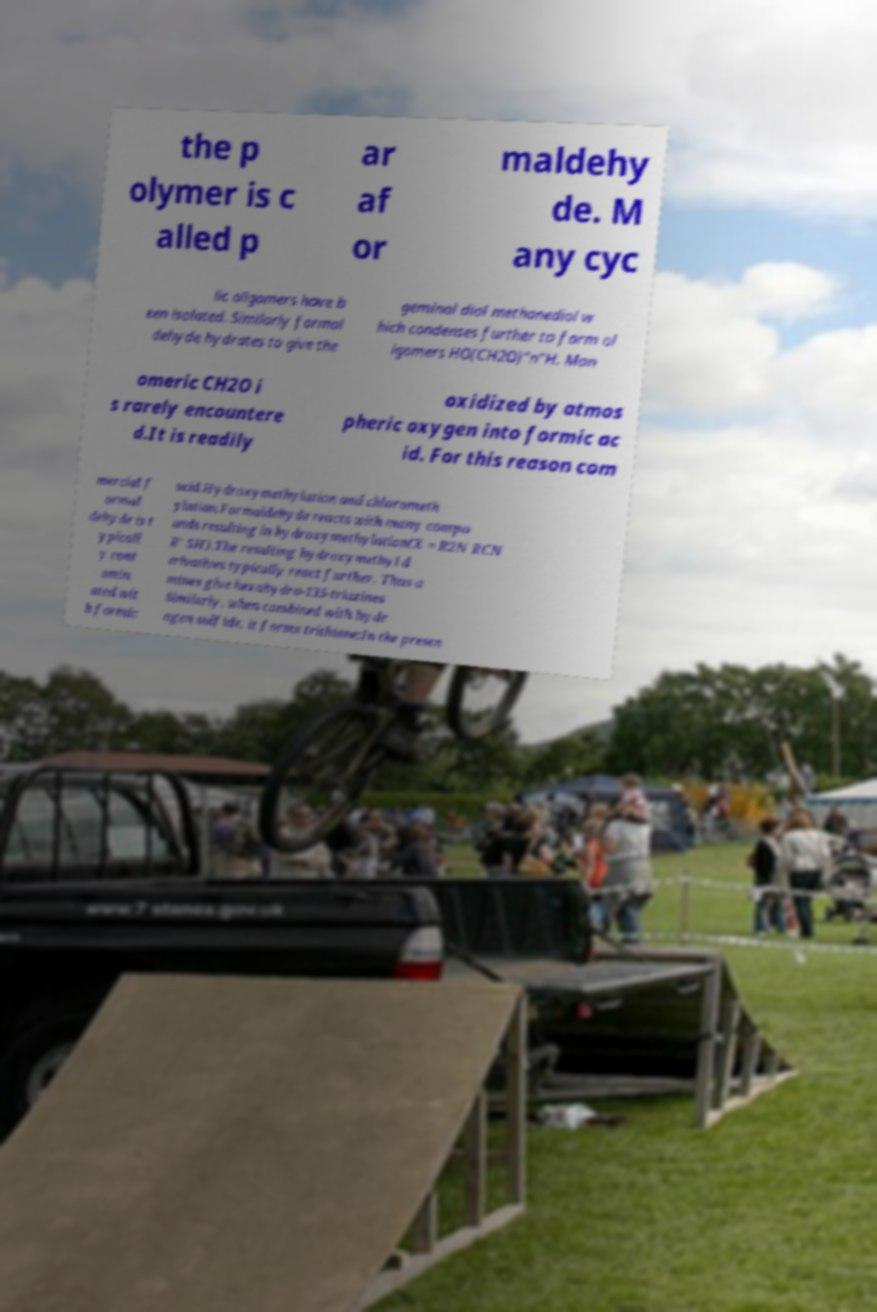Can you read and provide the text displayed in the image?This photo seems to have some interesting text. Can you extract and type it out for me? the p olymer is c alled p ar af or maldehy de. M any cyc lic oligomers have b een isolated. Similarly formal dehyde hydrates to give the geminal diol methanediol w hich condenses further to form ol igomers HO(CH2O)"n"H. Mon omeric CH2O i s rarely encountere d.It is readily oxidized by atmos pheric oxygen into formic ac id. For this reason com mercial f ormal dehyde is t ypicall y cont amin ated wit h formic acid.Hydroxymethylation and chlorometh ylation.Formaldehyde reacts with many compo unds resulting in hydroxymethylation(X = R2N RCN R' SH).The resulting hydroxymethyl d erivatives typically react further. Thus a mines give hexahydro-135-triazines Similarly, when combined with hydr ogen sulfide, it forms trithiane:In the presen 